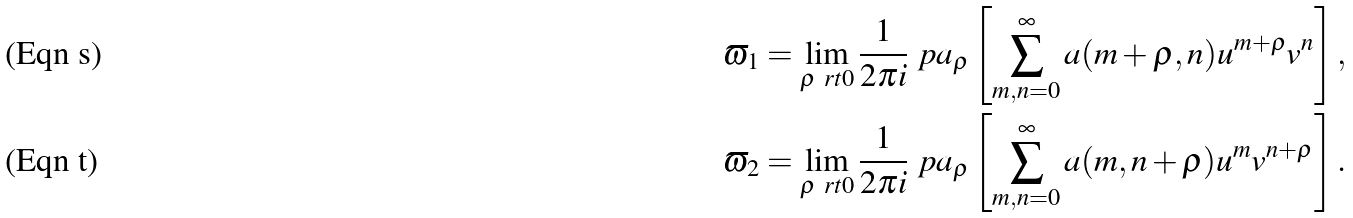<formula> <loc_0><loc_0><loc_500><loc_500>\varpi _ { 1 } & = \lim _ { \rho \ r t 0 } \frac { 1 } { 2 \pi i } \ p a _ { \rho } \left [ \sum _ { m , n = 0 } ^ { \infty } a ( m + \rho , n ) u ^ { m + \rho } v ^ { n } \right ] , \\ \varpi _ { 2 } & = \lim _ { \rho \ r t 0 } \frac { 1 } { 2 \pi i } \ p a _ { \rho } \left [ \sum _ { m , n = 0 } ^ { \infty } a ( m , n + \rho ) u ^ { m } v ^ { n + \rho } \right ] .</formula> 